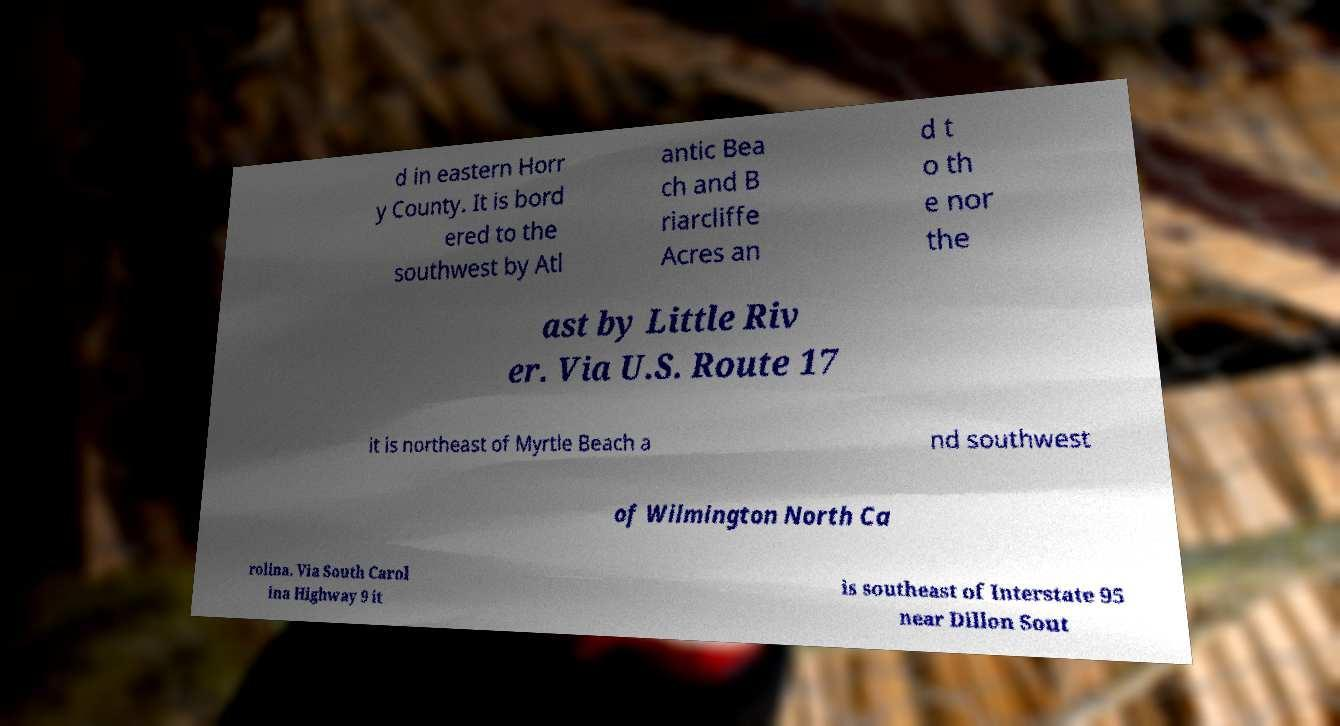Could you assist in decoding the text presented in this image and type it out clearly? d in eastern Horr y County. It is bord ered to the southwest by Atl antic Bea ch and B riarcliffe Acres an d t o th e nor the ast by Little Riv er. Via U.S. Route 17 it is northeast of Myrtle Beach a nd southwest of Wilmington North Ca rolina. Via South Carol ina Highway 9 it is southeast of Interstate 95 near Dillon Sout 